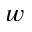<formula> <loc_0><loc_0><loc_500><loc_500>_ { w }</formula> 